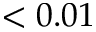<formula> <loc_0><loc_0><loc_500><loc_500>< 0 . 0 1</formula> 